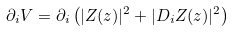<formula> <loc_0><loc_0><loc_500><loc_500>\partial _ { i } V = \partial _ { i } \left ( | Z ( z ) | ^ { 2 } + | D _ { i } Z ( z ) | ^ { 2 } \right )</formula> 